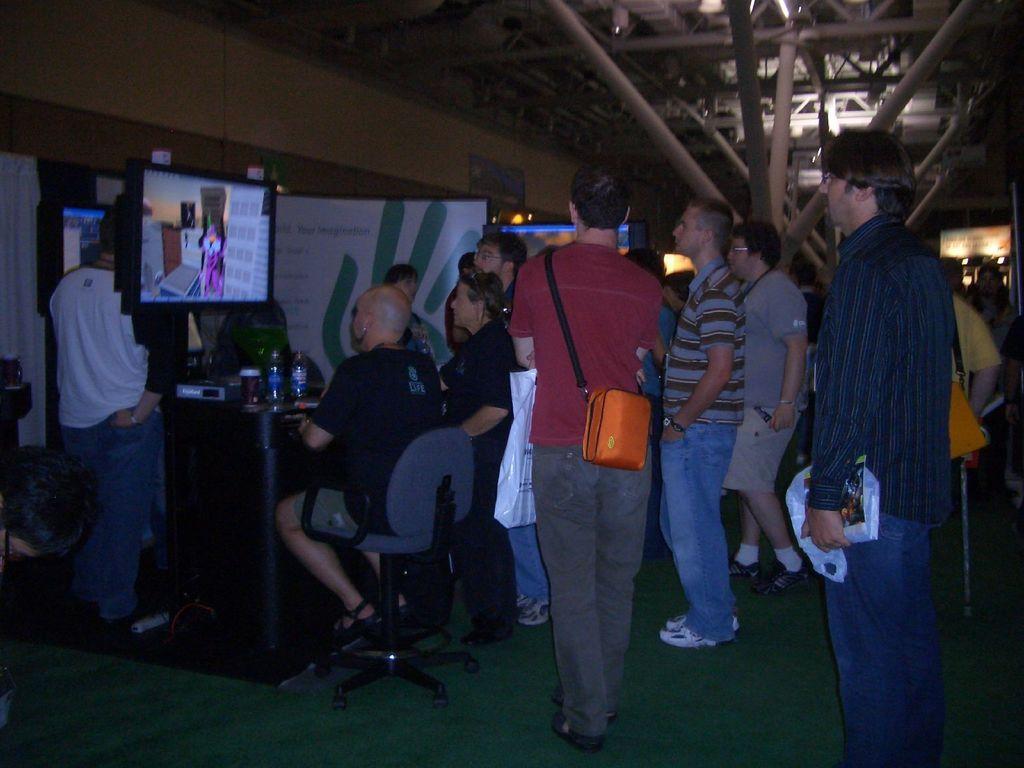Describe this image in one or two sentences. In the image there are a group of men and there is a table and there is a man sitting on the chair, on the table there are two bottles, a cup and other objects, in front of the table there is a screen and something is being displayed on the screen, in the background there is a banner and there are rods attached to the roof. 